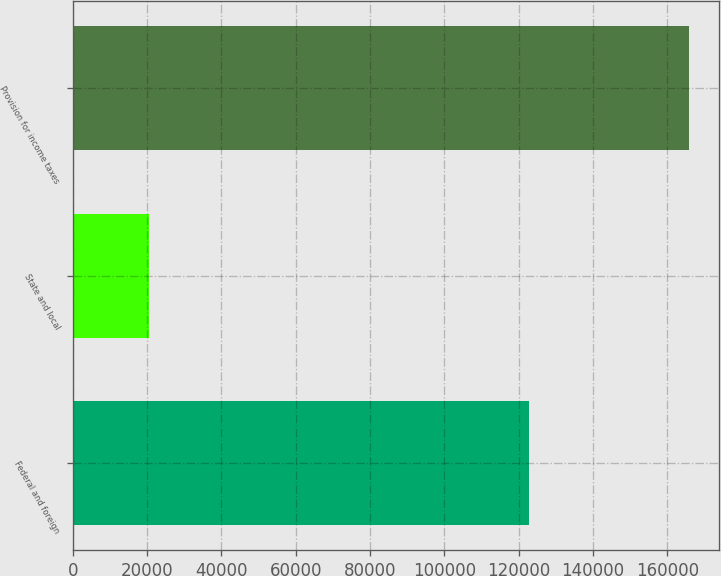<chart> <loc_0><loc_0><loc_500><loc_500><bar_chart><fcel>Federal and foreign<fcel>State and local<fcel>Provision for income taxes<nl><fcel>122872<fcel>20523<fcel>165739<nl></chart> 